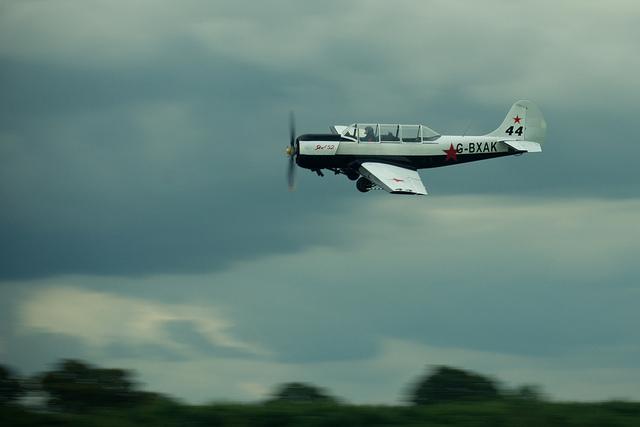Is this a jet airplane?
Keep it brief. No. What color is the plane?
Write a very short answer. White. Is the landing gear down?
Concise answer only. Yes. What is written on the plane's tail?
Be succinct. G-bxak. What's the weather in the photo?
Be succinct. Cloudy. Is the plane single or dual engine?
Short answer required. Single. Is the plane in the sky?
Answer briefly. Yes. Where is the plane?
Write a very short answer. Sky. What is the plane flying over?
Write a very short answer. Trees. Is this a passenger plane?
Keep it brief. No. Is this an airport?
Keep it brief. No. 